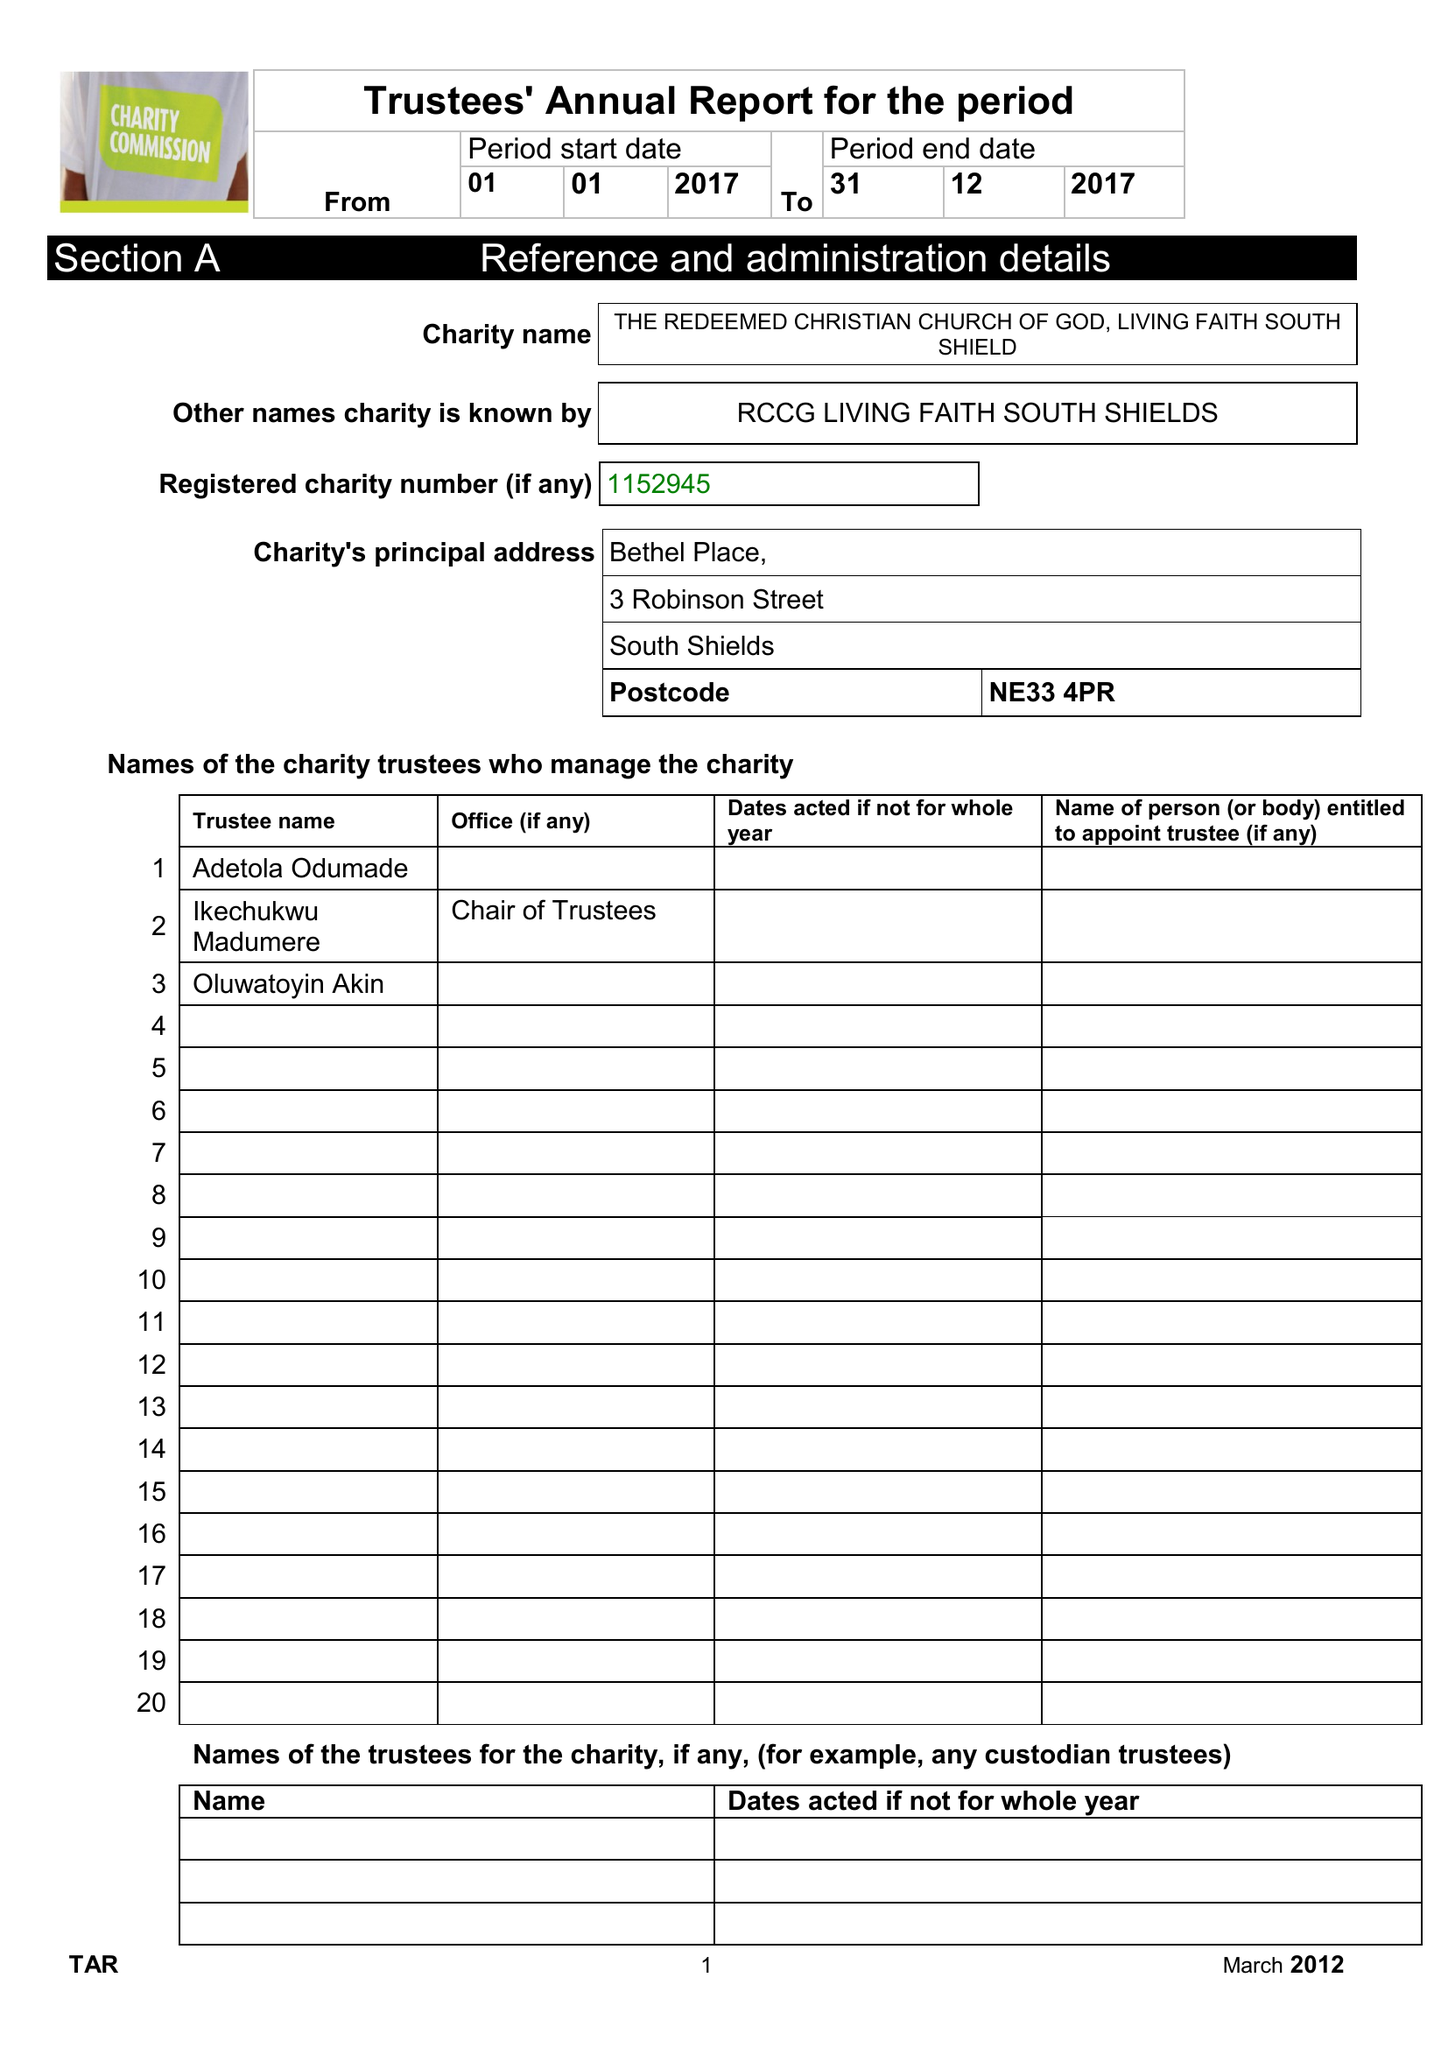What is the value for the address__post_town?
Answer the question using a single word or phrase. SOUTH SHIELDS 